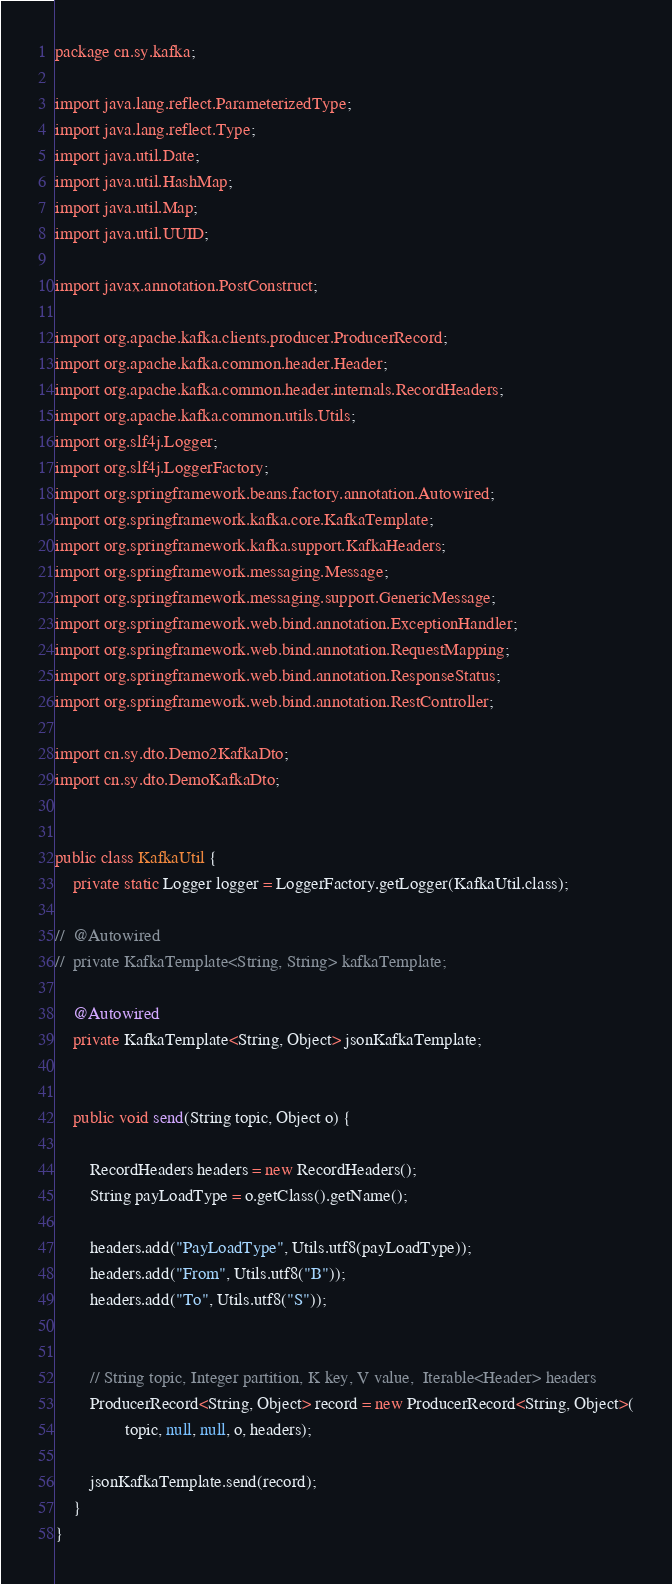Convert code to text. <code><loc_0><loc_0><loc_500><loc_500><_Java_>package cn.sy.kafka;

import java.lang.reflect.ParameterizedType;
import java.lang.reflect.Type;
import java.util.Date;
import java.util.HashMap;
import java.util.Map;
import java.util.UUID;

import javax.annotation.PostConstruct;

import org.apache.kafka.clients.producer.ProducerRecord;
import org.apache.kafka.common.header.Header;
import org.apache.kafka.common.header.internals.RecordHeaders;
import org.apache.kafka.common.utils.Utils;
import org.slf4j.Logger;
import org.slf4j.LoggerFactory;
import org.springframework.beans.factory.annotation.Autowired;
import org.springframework.kafka.core.KafkaTemplate;
import org.springframework.kafka.support.KafkaHeaders;
import org.springframework.messaging.Message;
import org.springframework.messaging.support.GenericMessage;
import org.springframework.web.bind.annotation.ExceptionHandler;
import org.springframework.web.bind.annotation.RequestMapping;
import org.springframework.web.bind.annotation.ResponseStatus;
import org.springframework.web.bind.annotation.RestController;

import cn.sy.dto.Demo2KafkaDto;
import cn.sy.dto.DemoKafkaDto;


public class KafkaUtil {
	private static Logger logger = LoggerFactory.getLogger(KafkaUtil.class);
		
//	@Autowired
//	private KafkaTemplate<String, String> kafkaTemplate;
	
	@Autowired
	private KafkaTemplate<String, Object> jsonKafkaTemplate;
	

	public void send(String topic, Object o) {
		
    	RecordHeaders headers = new RecordHeaders();
    	String payLoadType = o.getClass().getName();
        
        headers.add("PayLoadType", Utils.utf8(payLoadType));
    	headers.add("From", Utils.utf8("B"));
    	headers.add("To", Utils.utf8("S"));
    	
   	
    	// String topic, Integer partition, K key, V value,  Iterable<Header> headers
    	ProducerRecord<String, Object> record = new ProducerRecord<String, Object>(
    			topic, null, null, o, headers);
    	
		jsonKafkaTemplate.send(record);
	}
}
</code> 